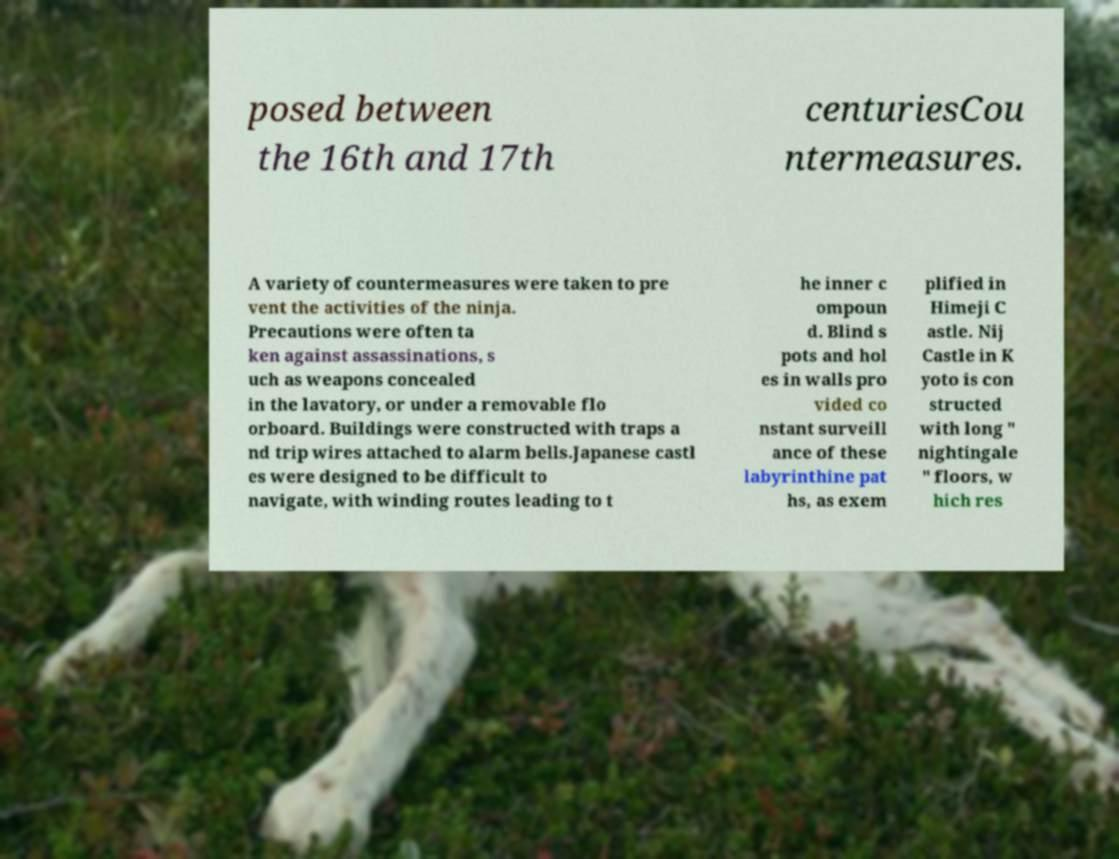What messages or text are displayed in this image? I need them in a readable, typed format. posed between the 16th and 17th centuriesCou ntermeasures. A variety of countermeasures were taken to pre vent the activities of the ninja. Precautions were often ta ken against assassinations, s uch as weapons concealed in the lavatory, or under a removable flo orboard. Buildings were constructed with traps a nd trip wires attached to alarm bells.Japanese castl es were designed to be difficult to navigate, with winding routes leading to t he inner c ompoun d. Blind s pots and hol es in walls pro vided co nstant surveill ance of these labyrinthine pat hs, as exem plified in Himeji C astle. Nij Castle in K yoto is con structed with long " nightingale " floors, w hich res 